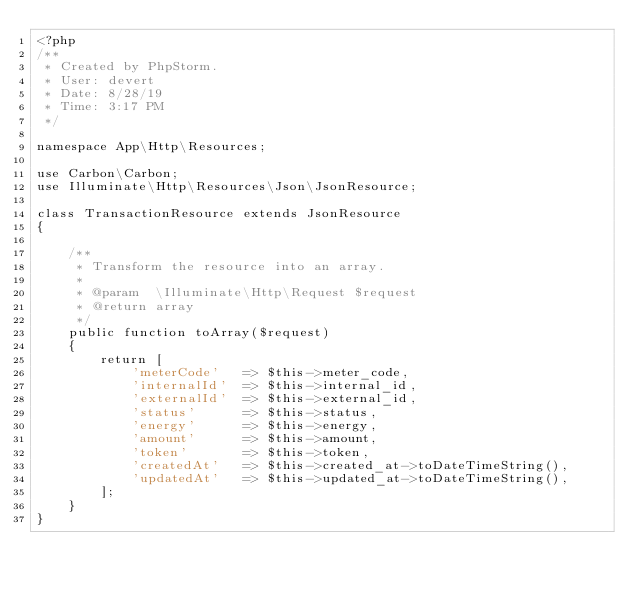Convert code to text. <code><loc_0><loc_0><loc_500><loc_500><_PHP_><?php
/**
 * Created by PhpStorm.
 * User: devert
 * Date: 8/28/19
 * Time: 3:17 PM
 */

namespace App\Http\Resources;

use Carbon\Carbon;
use Illuminate\Http\Resources\Json\JsonResource;

class TransactionResource extends JsonResource
{

    /**
     * Transform the resource into an array.
     *
     * @param  \Illuminate\Http\Request $request
     * @return array
     */
    public function toArray($request)
    {
        return [
            'meterCode'   => $this->meter_code,
            'internalId'  => $this->internal_id,
            'externalId'  => $this->external_id,
            'status'      => $this->status,
            'energy'      => $this->energy,
            'amount'      => $this->amount,
            'token'       => $this->token,
            'createdAt'   => $this->created_at->toDateTimeString(),
            'updatedAt'   => $this->updated_at->toDateTimeString(),
        ];
    }
}</code> 